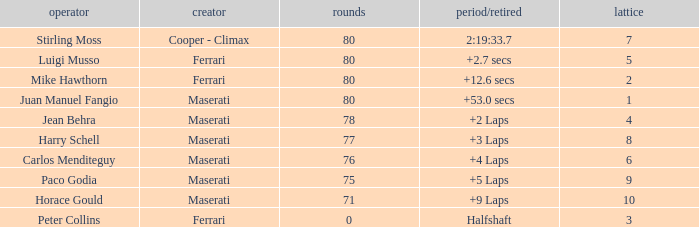What were the lowest laps of Luigi Musso driving a Ferrari with a Grid larger than 2? 80.0. 